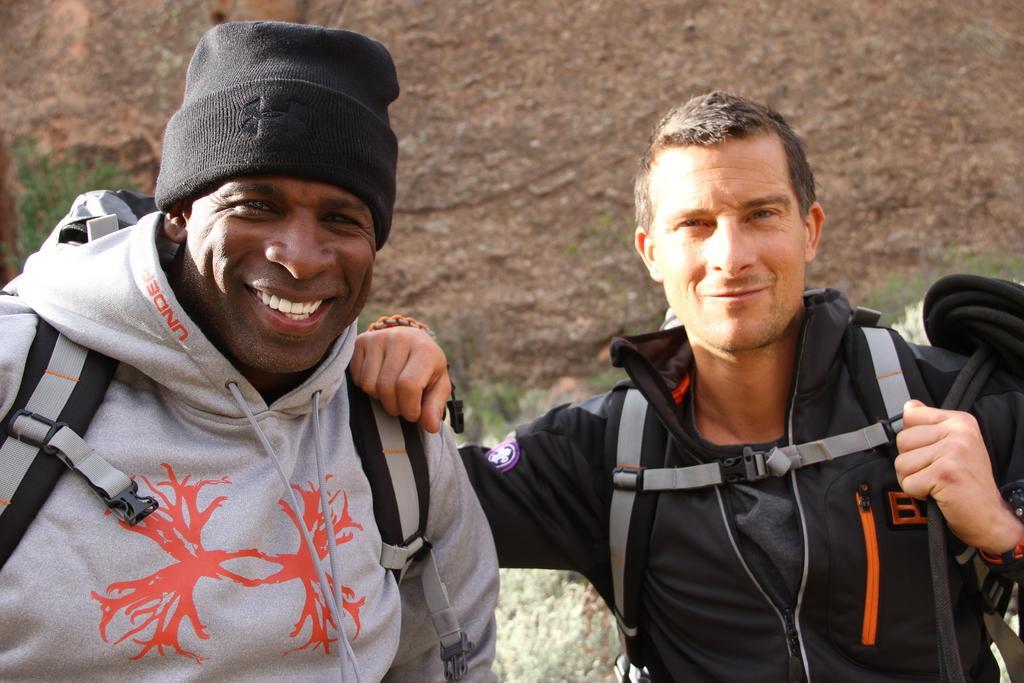Can you describe this image briefly? In this image we can see two persons standing on the ground. In the background there is a rock. 